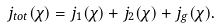<formula> <loc_0><loc_0><loc_500><loc_500>j _ { t o t } ( \chi ) = j _ { 1 } ( \chi ) + j _ { 2 } ( \chi ) + j _ { g } ( \chi ) .</formula> 